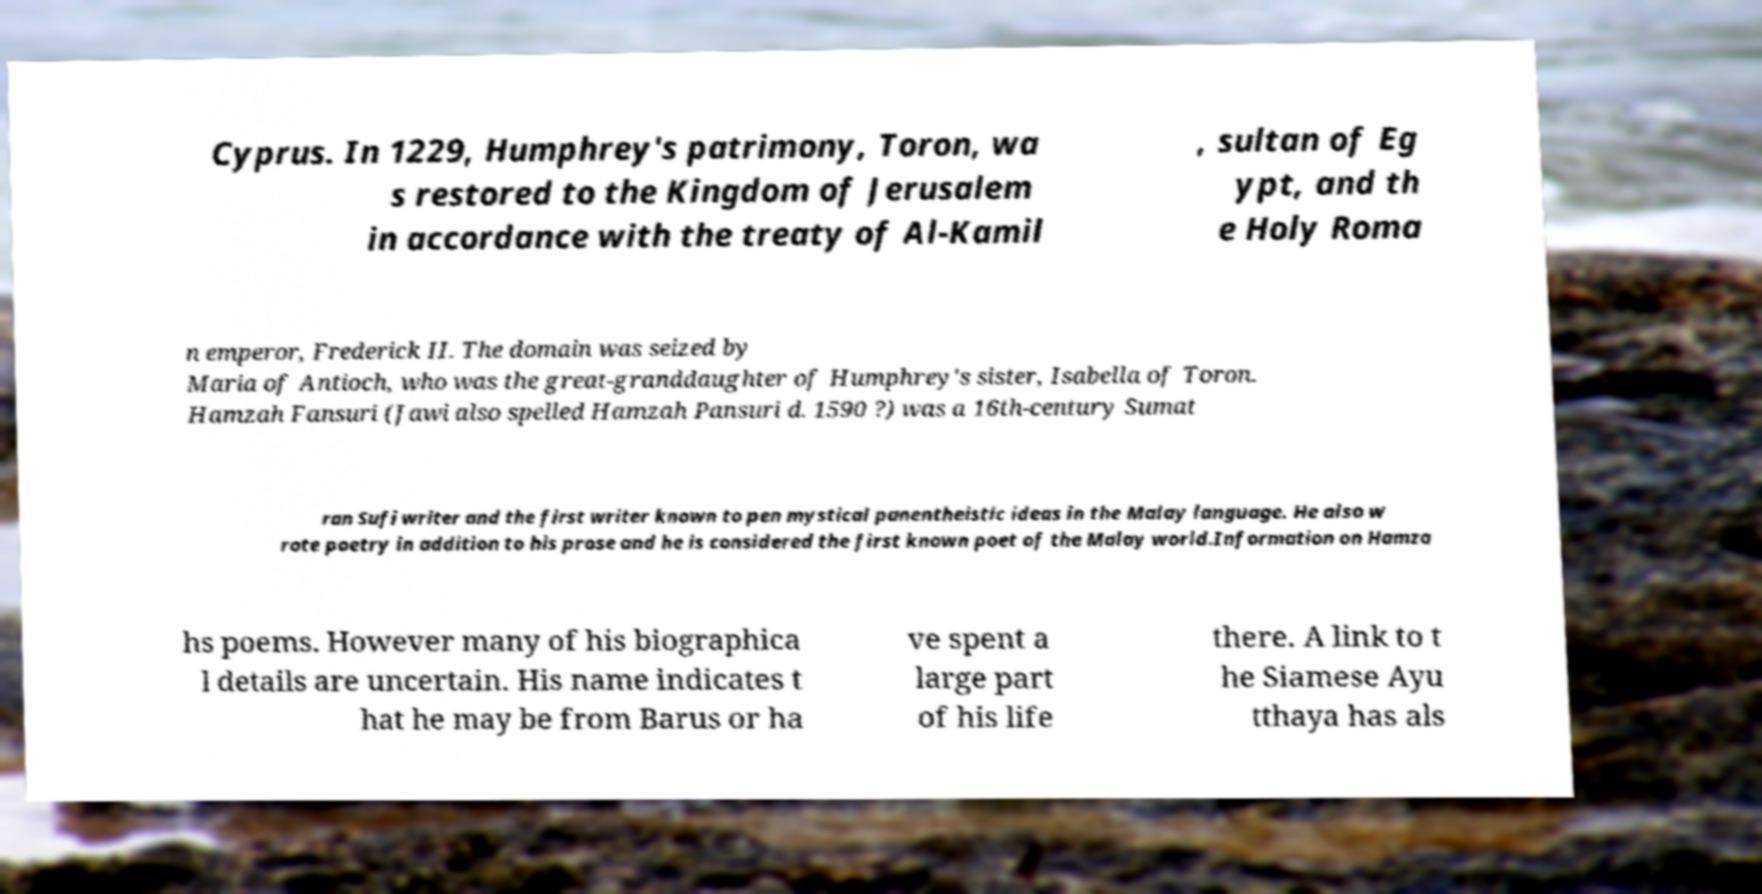Please read and relay the text visible in this image. What does it say? Cyprus. In 1229, Humphrey's patrimony, Toron, wa s restored to the Kingdom of Jerusalem in accordance with the treaty of Al-Kamil , sultan of Eg ypt, and th e Holy Roma n emperor, Frederick II. The domain was seized by Maria of Antioch, who was the great-granddaughter of Humphrey's sister, Isabella of Toron. Hamzah Fansuri (Jawi also spelled Hamzah Pansuri d. 1590 ?) was a 16th-century Sumat ran Sufi writer and the first writer known to pen mystical panentheistic ideas in the Malay language. He also w rote poetry in addition to his prose and he is considered the first known poet of the Malay world.Information on Hamza hs poems. However many of his biographica l details are uncertain. His name indicates t hat he may be from Barus or ha ve spent a large part of his life there. A link to t he Siamese Ayu tthaya has als 